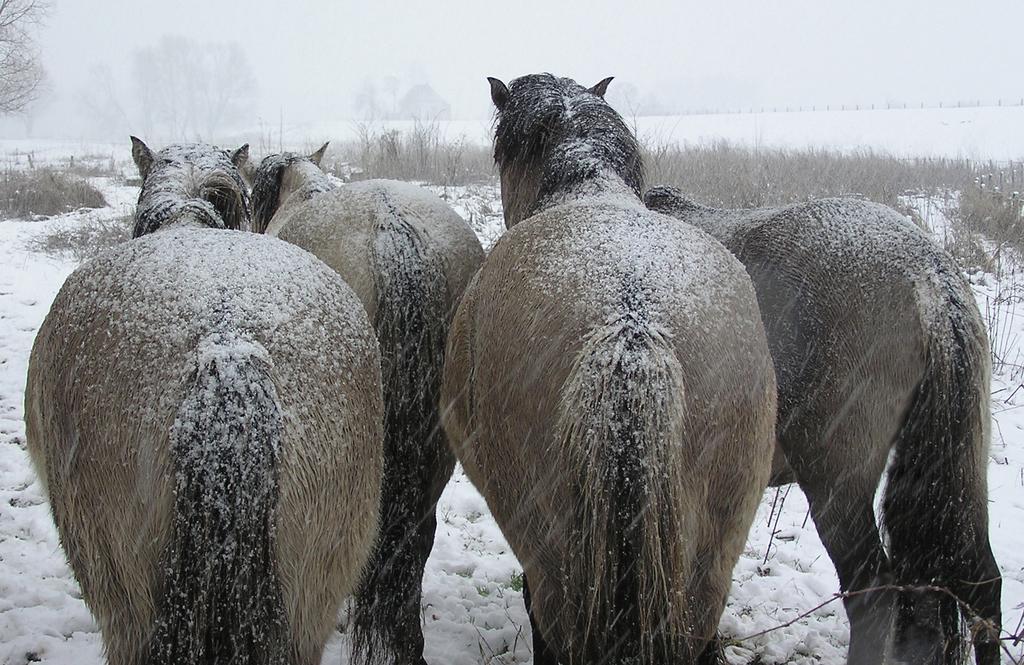In one or two sentences, can you explain what this image depicts? In this image there are four horses standing on the ground. There is snow on the horses. There are trees and plants on the ground. There is snow on the ground. It is snowing in the image. 